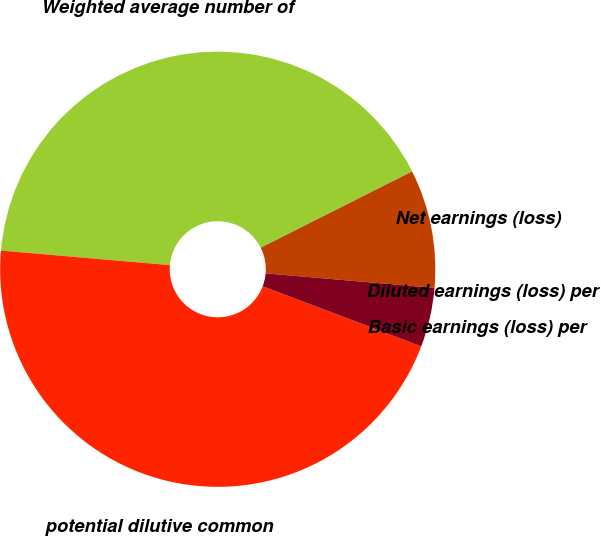Convert chart to OTSL. <chart><loc_0><loc_0><loc_500><loc_500><pie_chart><fcel>Net earnings (loss)<fcel>Weighted average number of<fcel>potential dilutive common<fcel>Basic earnings (loss) per<fcel>Diluted earnings (loss) per<nl><fcel>8.8%<fcel>41.2%<fcel>45.6%<fcel>4.4%<fcel>0.0%<nl></chart> 